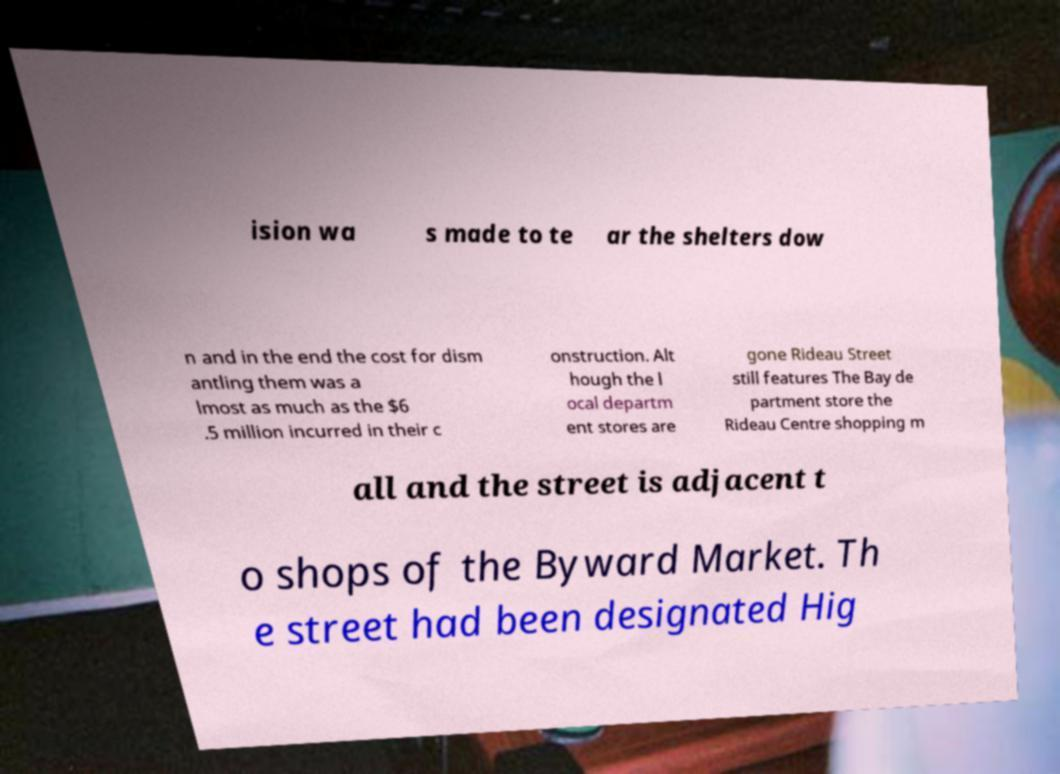Could you extract and type out the text from this image? ision wa s made to te ar the shelters dow n and in the end the cost for dism antling them was a lmost as much as the $6 .5 million incurred in their c onstruction. Alt hough the l ocal departm ent stores are gone Rideau Street still features The Bay de partment store the Rideau Centre shopping m all and the street is adjacent t o shops of the Byward Market. Th e street had been designated Hig 